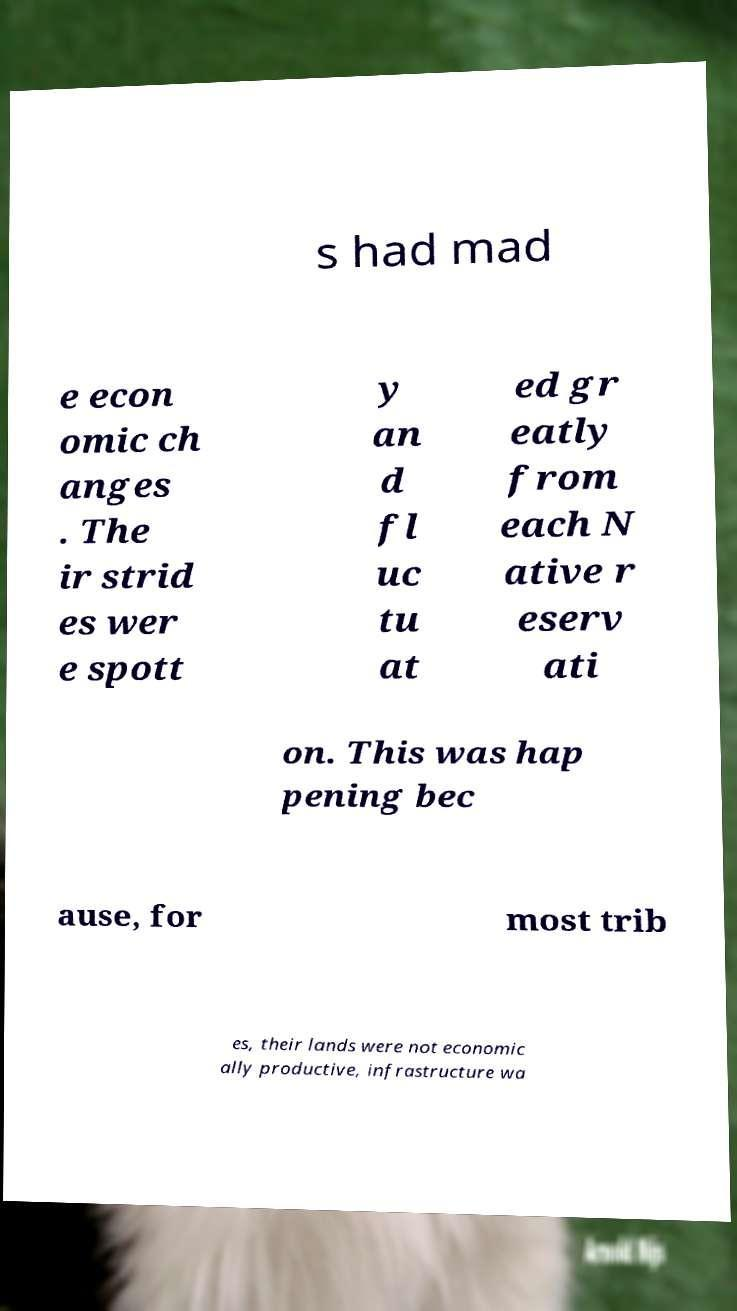Please identify and transcribe the text found in this image. s had mad e econ omic ch anges . The ir strid es wer e spott y an d fl uc tu at ed gr eatly from each N ative r eserv ati on. This was hap pening bec ause, for most trib es, their lands were not economic ally productive, infrastructure wa 